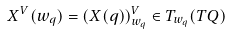Convert formula to latex. <formula><loc_0><loc_0><loc_500><loc_500>X ^ { V } ( w _ { q } ) = ( X ( q ) ) _ { w _ { q } } ^ { V } \in T _ { w _ { q } } ( T Q )</formula> 